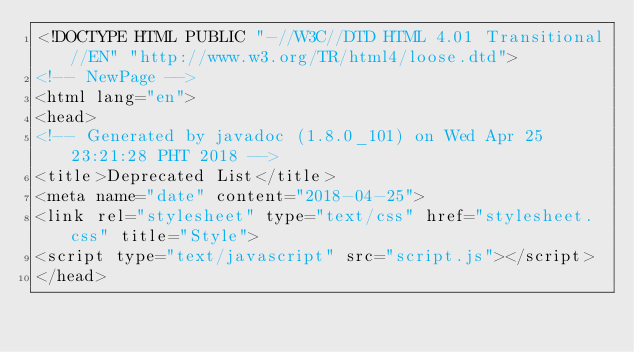Convert code to text. <code><loc_0><loc_0><loc_500><loc_500><_HTML_><!DOCTYPE HTML PUBLIC "-//W3C//DTD HTML 4.01 Transitional//EN" "http://www.w3.org/TR/html4/loose.dtd">
<!-- NewPage -->
<html lang="en">
<head>
<!-- Generated by javadoc (1.8.0_101) on Wed Apr 25 23:21:28 PHT 2018 -->
<title>Deprecated List</title>
<meta name="date" content="2018-04-25">
<link rel="stylesheet" type="text/css" href="stylesheet.css" title="Style">
<script type="text/javascript" src="script.js"></script>
</head></code> 